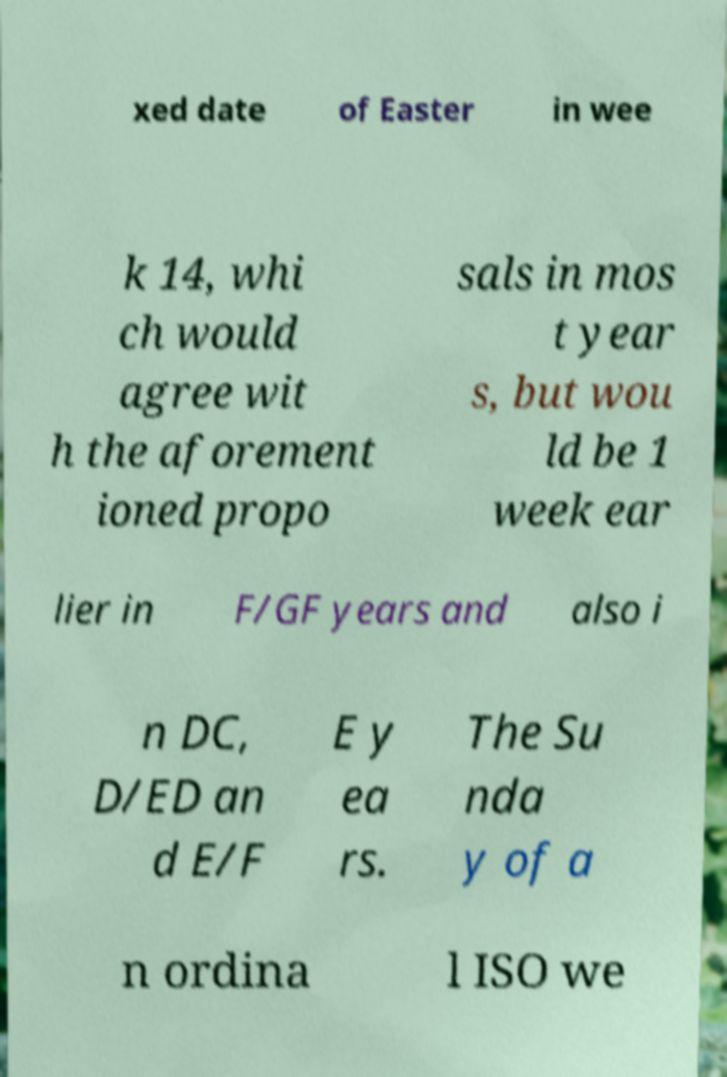Please identify and transcribe the text found in this image. xed date of Easter in wee k 14, whi ch would agree wit h the aforement ioned propo sals in mos t year s, but wou ld be 1 week ear lier in F/GF years and also i n DC, D/ED an d E/F E y ea rs. The Su nda y of a n ordina l ISO we 